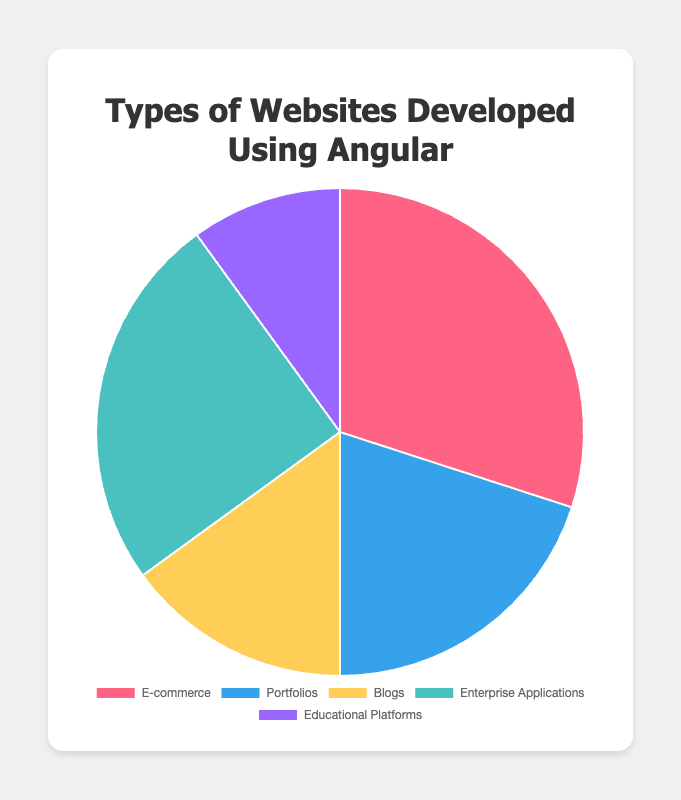what type of website has the highest percentage? The pie chart shows different types of websites developed using Angular with their respective percentages. The website type with the highest percentage is visually the largest segment.
Answer: E-commerce which two types of websites together make up half of the pie chart? To find which two types of websites together make up half of the pie chart, add the percentages of each type and see which combination equals 50%. E-commerce (30%) + Enterprise Applications (25%) = 55%, which is closest but over 50%. The next closest are Portfolios (20%) + E-commerce (30%) = 50%.
Answer: E-commerce and Portfolios what is the difference in percentage between the largest and the smallest segment? The largest segment is E-commerce with 30%, and the smallest is Educational Platforms with 10%. The difference is calculated by subtracting the smaller percentage from the larger percentage: 30% - 10% = 20%.
Answer: 20% how many types of websites have a percentage greater than 15%? From the pie chart, identify the website types with percentages greater than 15%. E-commerce (30%), Portfolios (20%), and Enterprise Applications (25%) all have percentages over 15%.
Answer: 3 by how much does the percentage of Portfolios exceed the percentage of Educational Platforms? The Portfolios segment is 20%, and the Educational Platforms segment is 10%. The excess is calculated by subtracting the smaller percentage from the larger percentage: 20% - 10% = 10%.
Answer: 10% which website category is represented by the green segment in the pie chart? The visual attribute required is the color green. Without hex codes or RGB values, determine the color used in the chart. From the visualization, Portfolios are represented by the blue-green color.
Answer: Portfolios 